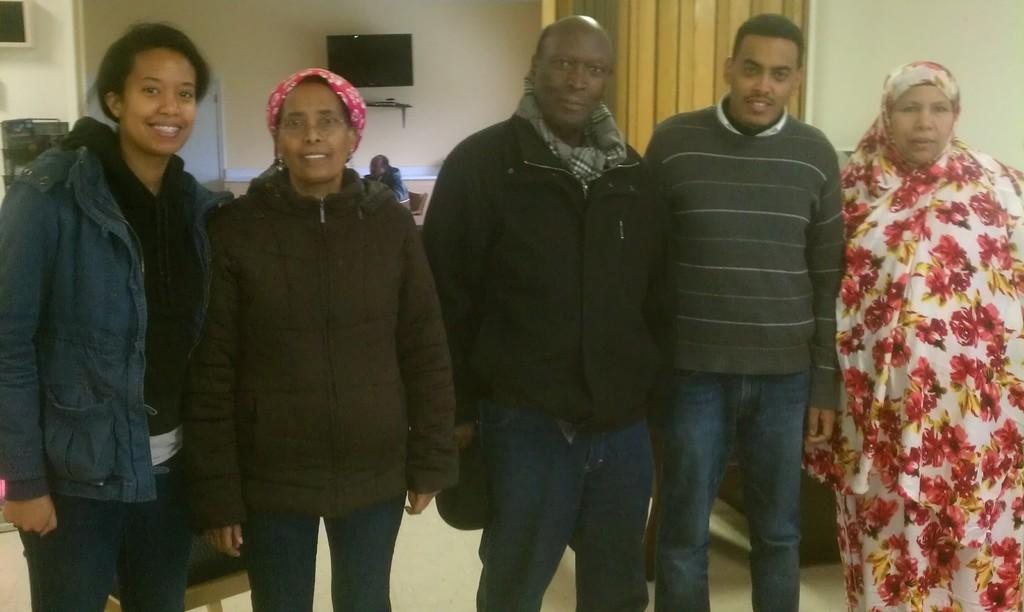What are the people in the image doing? The persons in the image are standing on the floor. What can be seen on the wall in the background? There is a set to the wall in the background. What type of structure is visible in the background? There are walls visible in the background. Can you describe the person in the background? There is a person sitting on a chair in the background. How many cows can be seen grazing in the background of the image? There are no cows present in the image; it features persons standing on the floor and a person sitting on a chair in the background. What type of worm is crawling on the floor in the image? There are no worms present in the image. 